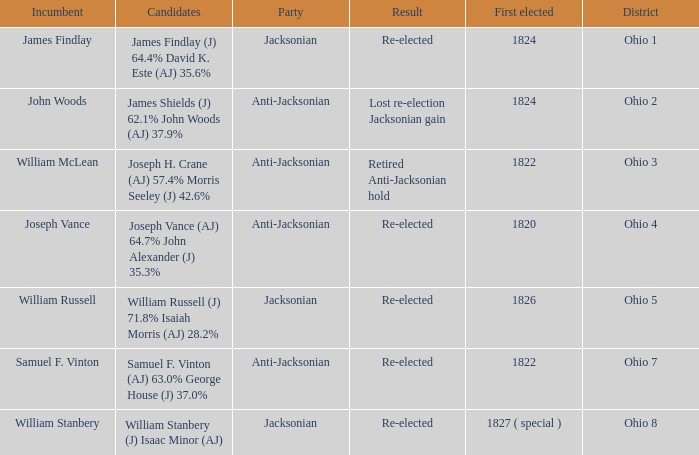What is the party of Joseph Vance? Anti-Jacksonian. 